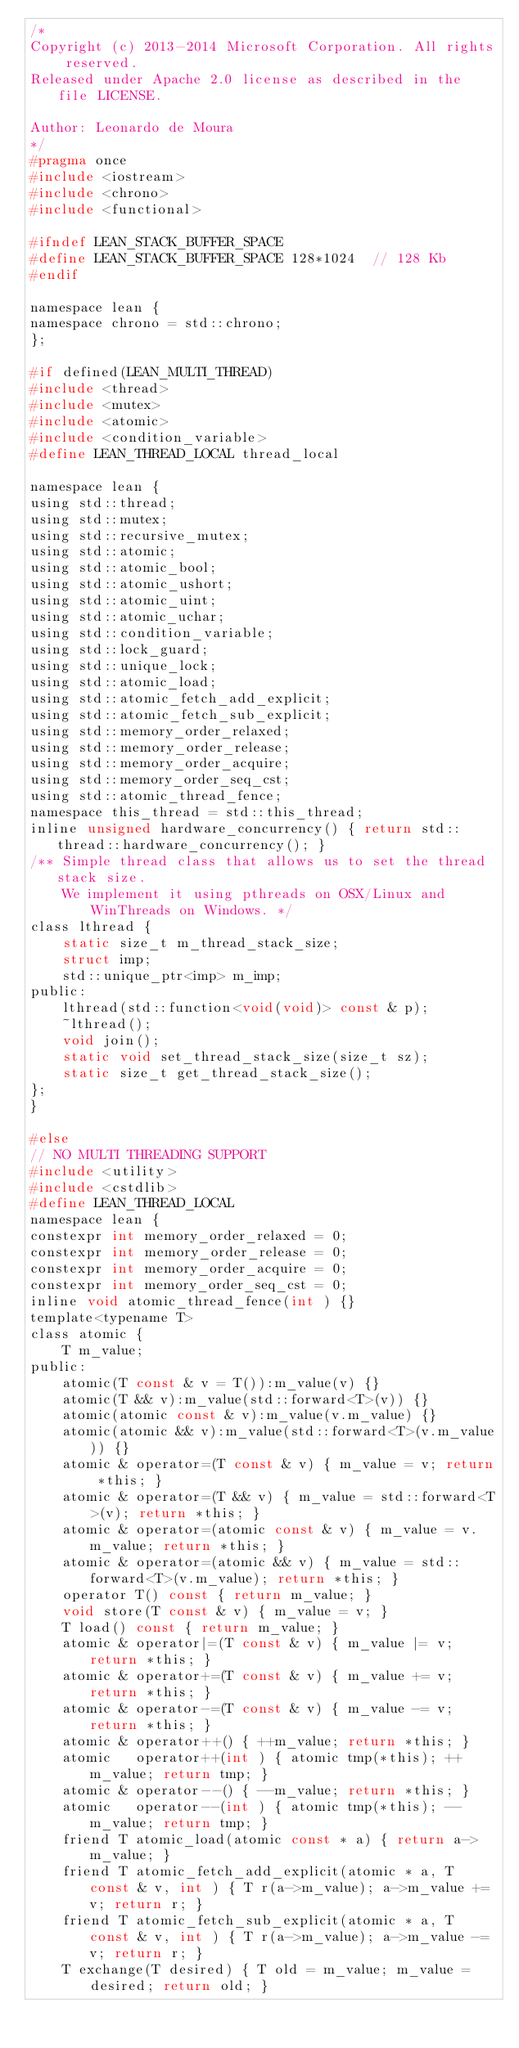Convert code to text. <code><loc_0><loc_0><loc_500><loc_500><_C_>/*
Copyright (c) 2013-2014 Microsoft Corporation. All rights reserved.
Released under Apache 2.0 license as described in the file LICENSE.

Author: Leonardo de Moura
*/
#pragma once
#include <iostream>
#include <chrono>
#include <functional>

#ifndef LEAN_STACK_BUFFER_SPACE
#define LEAN_STACK_BUFFER_SPACE 128*1024  // 128 Kb
#endif

namespace lean {
namespace chrono = std::chrono;
};

#if defined(LEAN_MULTI_THREAD)
#include <thread>
#include <mutex>
#include <atomic>
#include <condition_variable>
#define LEAN_THREAD_LOCAL thread_local

namespace lean {
using std::thread;
using std::mutex;
using std::recursive_mutex;
using std::atomic;
using std::atomic_bool;
using std::atomic_ushort;
using std::atomic_uint;
using std::atomic_uchar;
using std::condition_variable;
using std::lock_guard;
using std::unique_lock;
using std::atomic_load;
using std::atomic_fetch_add_explicit;
using std::atomic_fetch_sub_explicit;
using std::memory_order_relaxed;
using std::memory_order_release;
using std::memory_order_acquire;
using std::memory_order_seq_cst;
using std::atomic_thread_fence;
namespace this_thread = std::this_thread;
inline unsigned hardware_concurrency() { return std::thread::hardware_concurrency(); }
/** Simple thread class that allows us to set the thread stack size.
    We implement it using pthreads on OSX/Linux and WinThreads on Windows. */
class lthread {
    static size_t m_thread_stack_size;
    struct imp;
    std::unique_ptr<imp> m_imp;
public:
    lthread(std::function<void(void)> const & p);
    ~lthread();
    void join();
    static void set_thread_stack_size(size_t sz);
    static size_t get_thread_stack_size();
};
}

#else
// NO MULTI THREADING SUPPORT
#include <utility>
#include <cstdlib>
#define LEAN_THREAD_LOCAL
namespace lean {
constexpr int memory_order_relaxed = 0;
constexpr int memory_order_release = 0;
constexpr int memory_order_acquire = 0;
constexpr int memory_order_seq_cst = 0;
inline void atomic_thread_fence(int ) {}
template<typename T>
class atomic {
    T m_value;
public:
    atomic(T const & v = T()):m_value(v) {}
    atomic(T && v):m_value(std::forward<T>(v)) {}
    atomic(atomic const & v):m_value(v.m_value) {}
    atomic(atomic && v):m_value(std::forward<T>(v.m_value)) {}
    atomic & operator=(T const & v) { m_value = v; return *this; }
    atomic & operator=(T && v) { m_value = std::forward<T>(v); return *this; }
    atomic & operator=(atomic const & v) { m_value = v.m_value; return *this; }
    atomic & operator=(atomic && v) { m_value = std::forward<T>(v.m_value); return *this; }
    operator T() const { return m_value; }
    void store(T const & v) { m_value = v; }
    T load() const { return m_value; }
    atomic & operator|=(T const & v) { m_value |= v; return *this; }
    atomic & operator+=(T const & v) { m_value += v; return *this; }
    atomic & operator-=(T const & v) { m_value -= v; return *this; }
    atomic & operator++() { ++m_value; return *this; }
    atomic   operator++(int ) { atomic tmp(*this); ++m_value; return tmp; }
    atomic & operator--() { --m_value; return *this; }
    atomic   operator--(int ) { atomic tmp(*this); --m_value; return tmp; }
    friend T atomic_load(atomic const * a) { return a->m_value; }
    friend T atomic_fetch_add_explicit(atomic * a, T const & v, int ) { T r(a->m_value); a->m_value += v; return r; }
    friend T atomic_fetch_sub_explicit(atomic * a, T const & v, int ) { T r(a->m_value); a->m_value -= v; return r; }
    T exchange(T desired) { T old = m_value; m_value = desired; return old; }</code> 